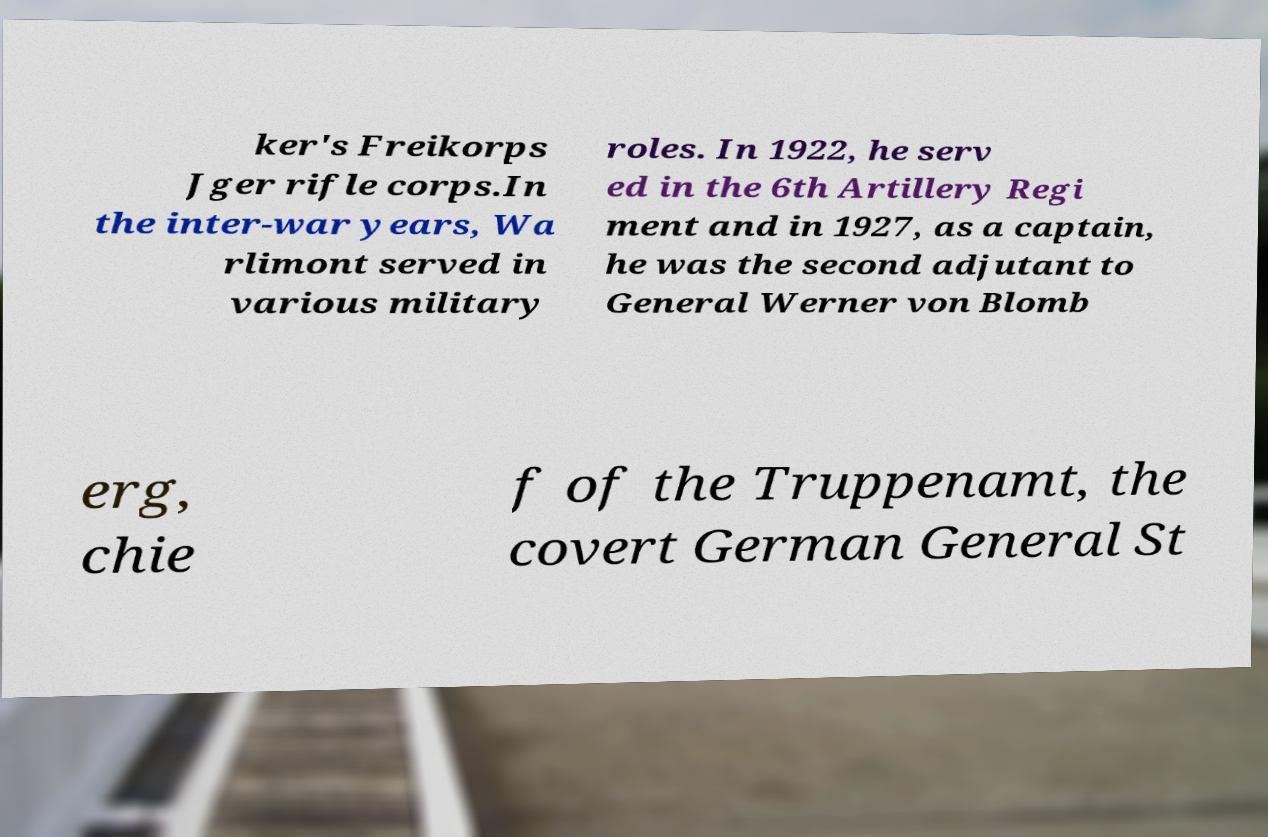Can you read and provide the text displayed in the image?This photo seems to have some interesting text. Can you extract and type it out for me? ker's Freikorps Jger rifle corps.In the inter-war years, Wa rlimont served in various military roles. In 1922, he serv ed in the 6th Artillery Regi ment and in 1927, as a captain, he was the second adjutant to General Werner von Blomb erg, chie f of the Truppenamt, the covert German General St 